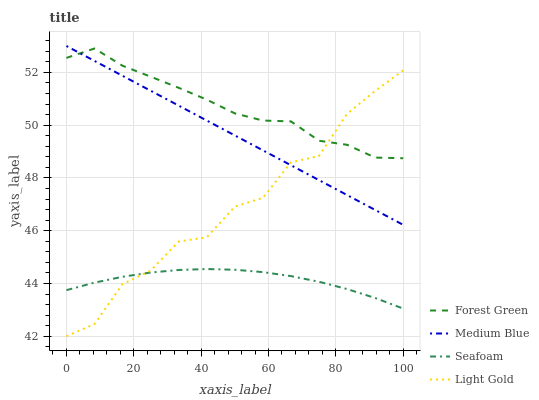Does Medium Blue have the minimum area under the curve?
Answer yes or no. No. Does Medium Blue have the maximum area under the curve?
Answer yes or no. No. Is Forest Green the smoothest?
Answer yes or no. No. Is Forest Green the roughest?
Answer yes or no. No. Does Medium Blue have the lowest value?
Answer yes or no. No. Does Forest Green have the highest value?
Answer yes or no. No. Is Seafoam less than Medium Blue?
Answer yes or no. Yes. Is Forest Green greater than Seafoam?
Answer yes or no. Yes. Does Seafoam intersect Medium Blue?
Answer yes or no. No. 